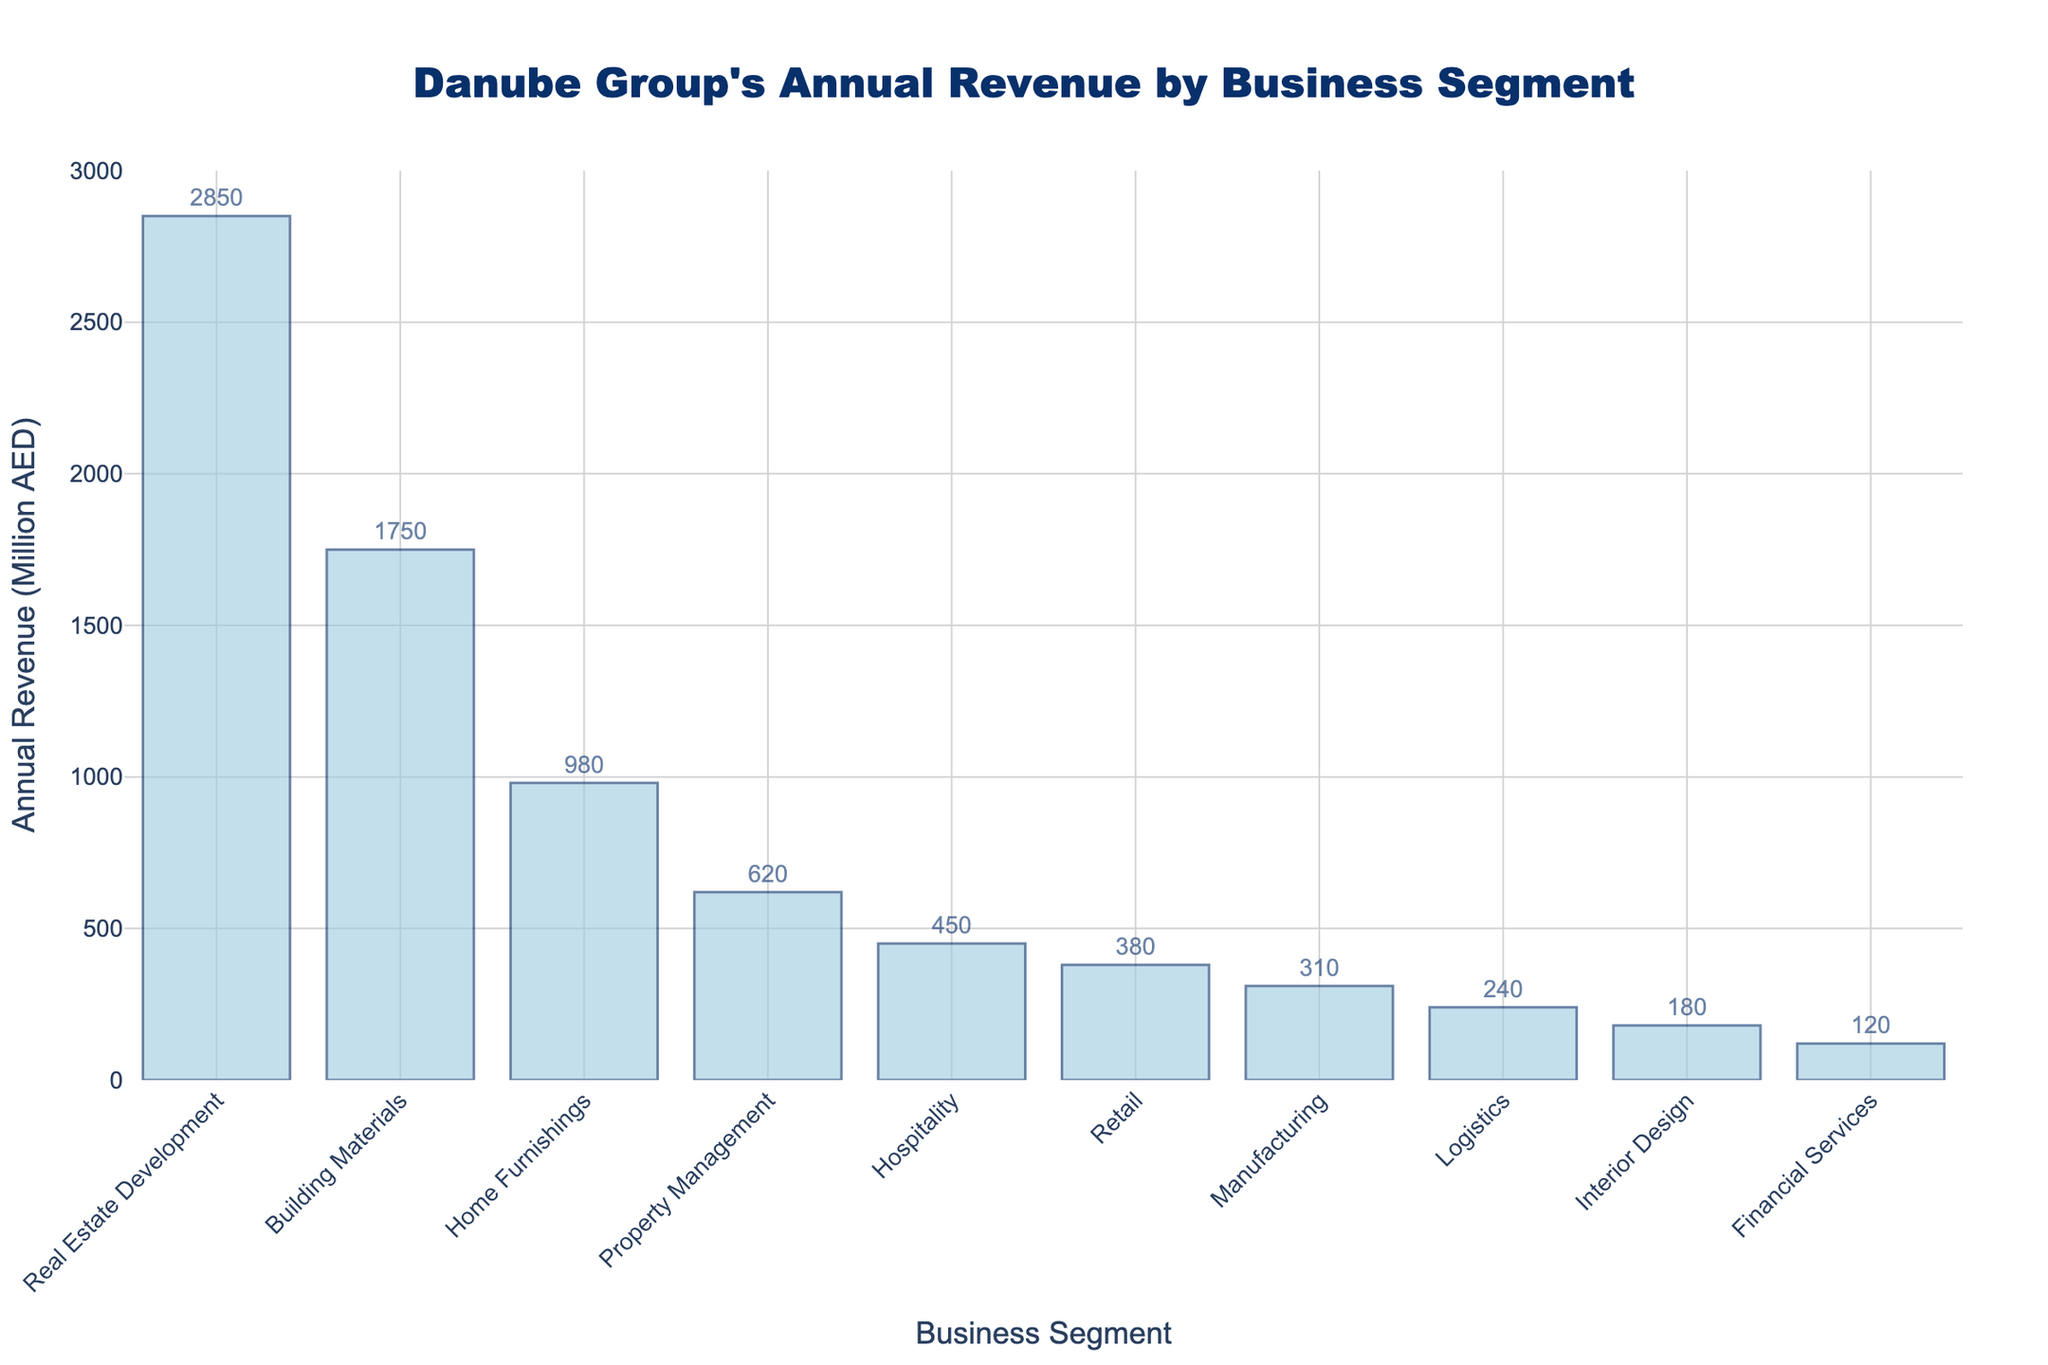Which business segment generates the highest annual revenue? The highest bar represents the segment with the most revenue. It is the "Real Estate Development" segment.
Answer: Real Estate Development What is the annual revenue for the Home Furnishings segment? Locate the bar labeled "Home Furnishings" and read the value associated with it, which is 980 million AED.
Answer: 980 million AED How much more revenue does Real Estate Development generate compared to Building Materials? Find the bars for "Real Estate Development" and "Building Materials" and subtract their values: 2850 - 1750.
Answer: 1100 million AED Which segments have annual revenues less than 500 million AED? Identify all bars with values lower than 500 million AED. These are "Hospitality", "Retail", "Manufacturing", "Logistics", "Interior Design", and "Financial Services".
Answer: Hospitality, Retail, Manufacturing, Logistics, Interior Design, Financial Services What is the combined revenue of the top three segments? Add the revenues of the top three segments: Real Estate Development (2850), Building Materials (1750), and Home Furnishings (980).
Answer: 5580 million AED Which segment is closest in revenue to 1000 million AED? Identify the bar whose height is closest to 1000 million AED. The "Home Furnishings" segment, with 980 million AED, is the closest.
Answer: Home Furnishings What is the average revenue of all business segments? Sum all revenues and divide by the number of segments: (2850 + 1750 + 980 + 620 + 450 + 380 + 310 + 240 + 180 + 120) / 10.
Answer: 888 million AED By how much does Property Management revenue exceed that of Retail? Subtract the revenue of "Retail" from "Property Management": 620 - 380.
Answer: 240 million AED How does the height of the Manufacturing segment bar compare to the Hospitality segment? Visually compare the heights of "Manufacturing" and "Hospitality" bars. The "Hospitality" bar is taller than the "Manufacturing" bar.
Answer: Hospitality is taller What is the total revenue generated by segments with over 1000 million AED annually? Sum the revenues of segments with over 1000 million AED: Real Estate Development (2850) and Building Materials (1750).
Answer: 4600 million AED 